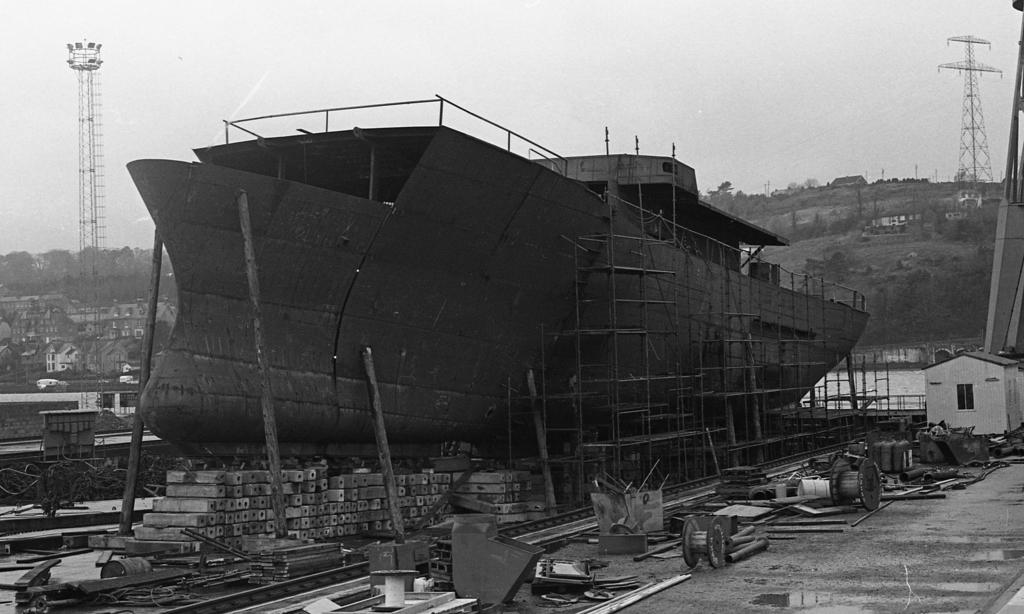What is the main subject of the image? The main subject of the image is a boat. What is located beside the boat? There are wooden sticks beside the boat. What can be seen in the background of the image? There are trees, buildings, and towers in the background of the image. How many dogs are present in the image? There are no dogs present in the image. Is there a goat visible in the image? There is no goat visible in the image. 